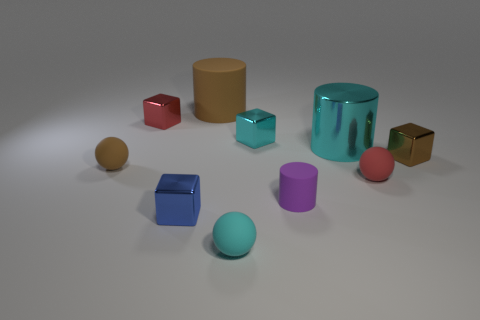Subtract all cylinders. How many objects are left? 7 Add 6 large cyan metal objects. How many large cyan metal objects exist? 7 Subtract 0 green cubes. How many objects are left? 10 Subtract all brown matte cubes. Subtract all brown cylinders. How many objects are left? 9 Add 6 purple matte objects. How many purple matte objects are left? 7 